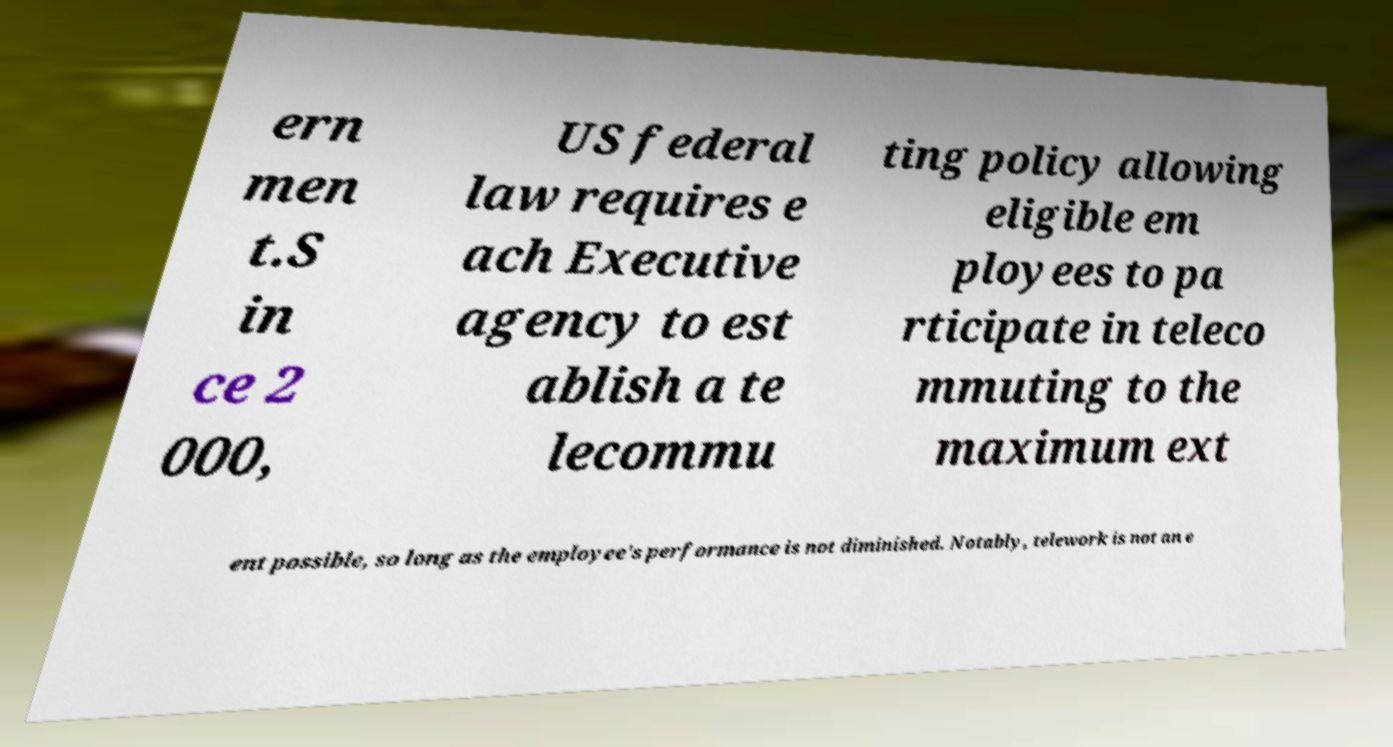Could you extract and type out the text from this image? ern men t.S in ce 2 000, US federal law requires e ach Executive agency to est ablish a te lecommu ting policy allowing eligible em ployees to pa rticipate in teleco mmuting to the maximum ext ent possible, so long as the employee's performance is not diminished. Notably, telework is not an e 